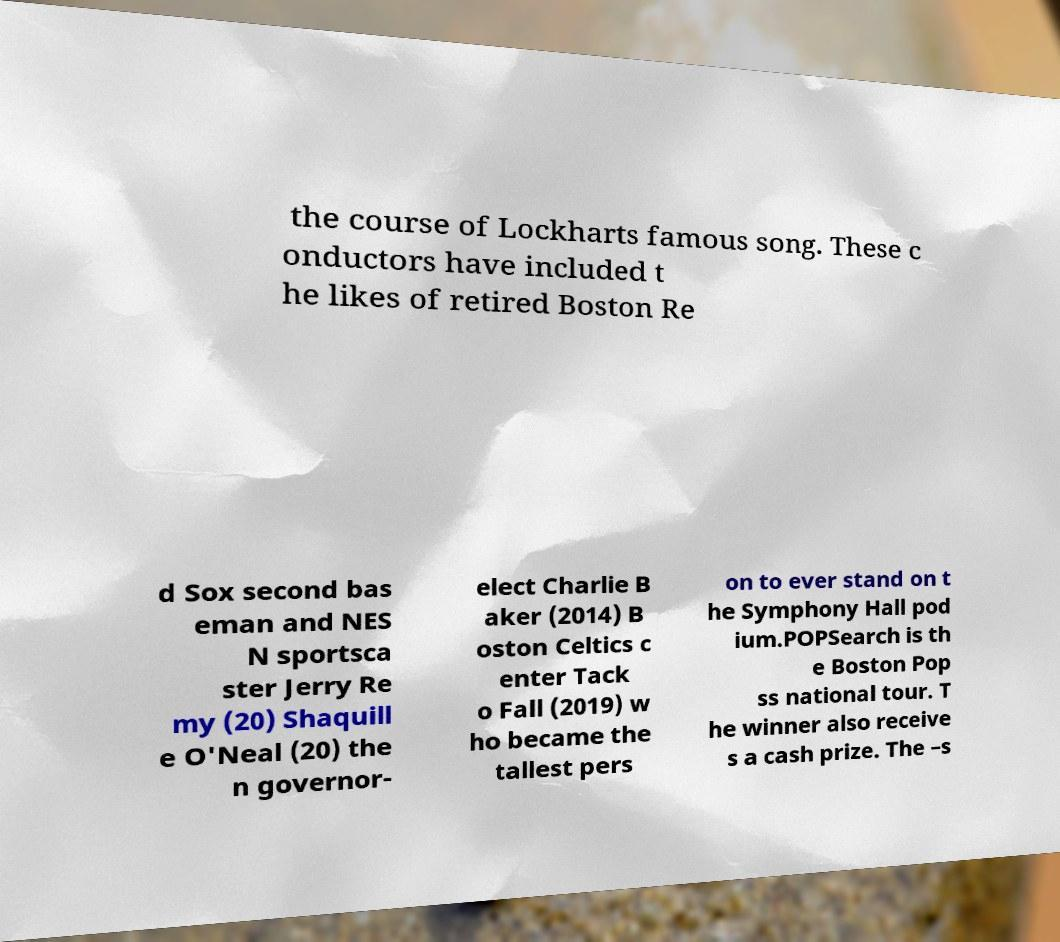Could you assist in decoding the text presented in this image and type it out clearly? the course of Lockharts famous song. These c onductors have included t he likes of retired Boston Re d Sox second bas eman and NES N sportsca ster Jerry Re my (20) Shaquill e O'Neal (20) the n governor- elect Charlie B aker (2014) B oston Celtics c enter Tack o Fall (2019) w ho became the tallest pers on to ever stand on t he Symphony Hall pod ium.POPSearch is th e Boston Pop ss national tour. T he winner also receive s a cash prize. The –s 